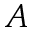Convert formula to latex. <formula><loc_0><loc_0><loc_500><loc_500>A</formula> 